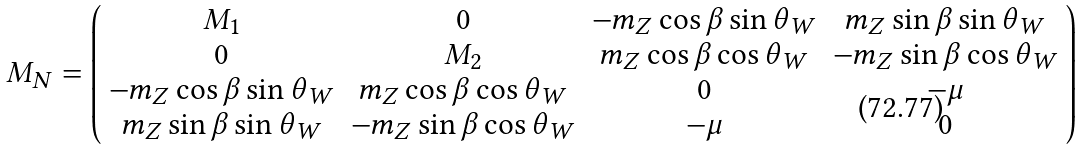<formula> <loc_0><loc_0><loc_500><loc_500>M _ { N } = \left ( \begin{array} { c c c c } M _ { 1 } & 0 & - m _ { Z } \cos \beta \sin \theta _ { W } & m _ { Z } \sin \beta \sin \theta _ { W } \\ 0 & M _ { 2 } & m _ { Z } \cos \beta \cos \theta _ { W } & - m _ { Z } \sin \beta \cos \theta _ { W } \\ - m _ { Z } \cos \beta \sin \theta _ { W } & m _ { Z } \cos \beta \cos \theta _ { W } & 0 & - \mu \\ m _ { Z } \sin \beta \sin \theta _ { W } & - m _ { Z } \sin \beta \cos \theta _ { W } & - \mu & 0 \end{array} \right )</formula> 